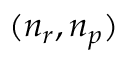<formula> <loc_0><loc_0><loc_500><loc_500>( n _ { r } , n _ { p } )</formula> 